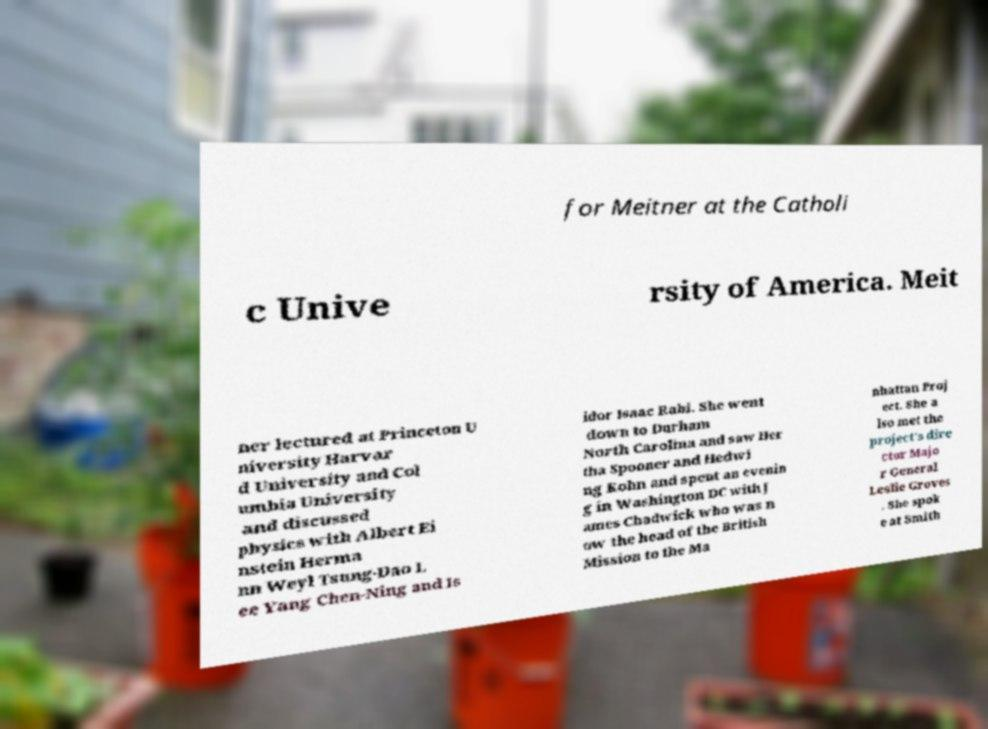Could you extract and type out the text from this image? for Meitner at the Catholi c Unive rsity of America. Meit ner lectured at Princeton U niversity Harvar d University and Col umbia University and discussed physics with Albert Ei nstein Herma nn Weyl Tsung-Dao L ee Yang Chen-Ning and Is idor Isaac Rabi. She went down to Durham North Carolina and saw Her tha Spooner and Hedwi ng Kohn and spent an evenin g in Washington DC with J ames Chadwick who was n ow the head of the British Mission to the Ma nhattan Proj ect. She a lso met the project's dire ctor Majo r General Leslie Groves . She spok e at Smith 